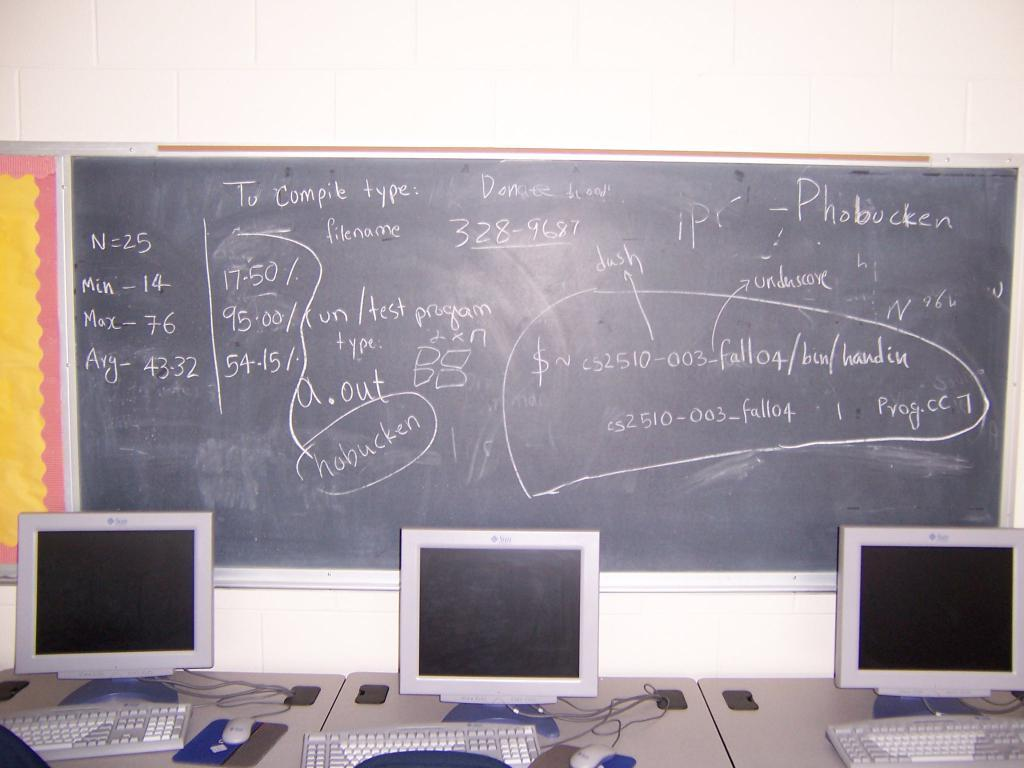<image>
Share a concise interpretation of the image provided. Three computers monitors and keyboards in front of a chalkboard that says Phobucken on it. 